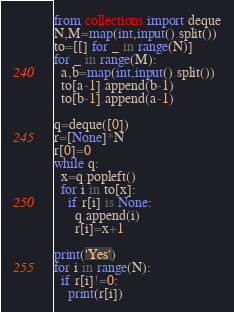Convert code to text. <code><loc_0><loc_0><loc_500><loc_500><_Python_>from collections import deque
N,M=map(int,input().split())
to=[[] for _ in range(N)]
for _ in range(M):
  a,b=map(int,input().split())
  to[a-1].append(b-1)
  to[b-1].append(a-1)

q=deque([0])
r=[None]*N
r[0]=0
while q:
  x=q.popleft()
  for i in to[x]:
    if r[i] is None:
      q.append(i)
      r[i]=x+1
      
print('Yes')
for i in range(N):
  if r[i]!=0:
    print(r[i])</code> 